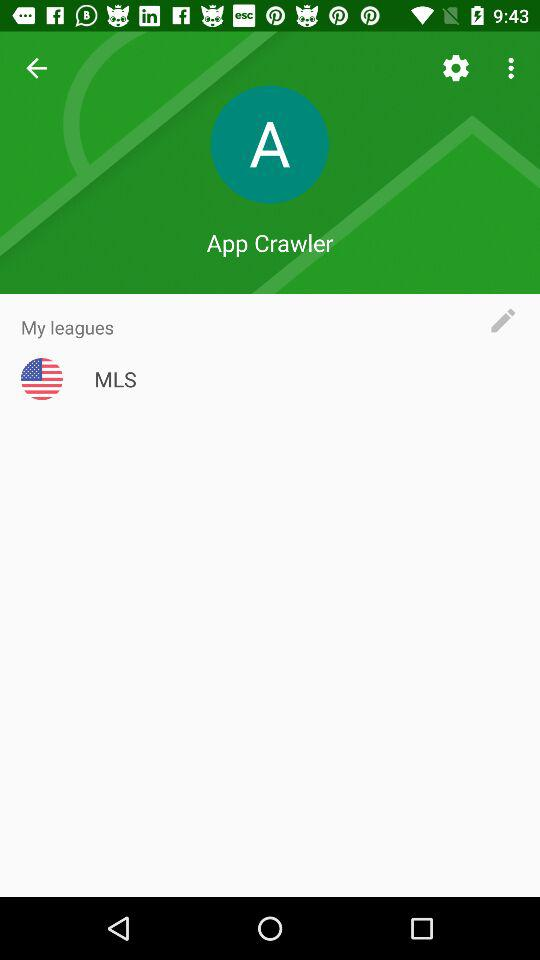What is the league name? The league name is MLS. 